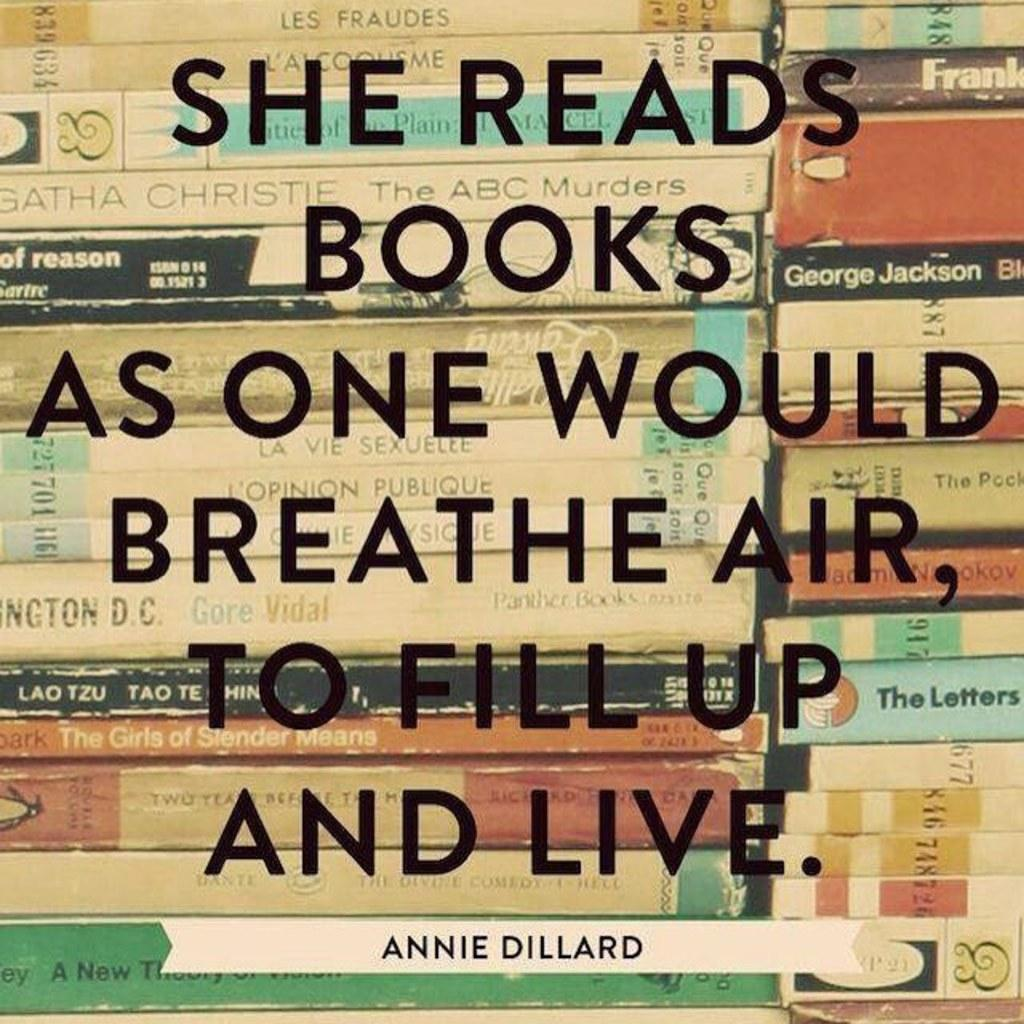<image>
Give a short and clear explanation of the subsequent image. A stack of books and a statement by Annie Dillard written on top of them. 